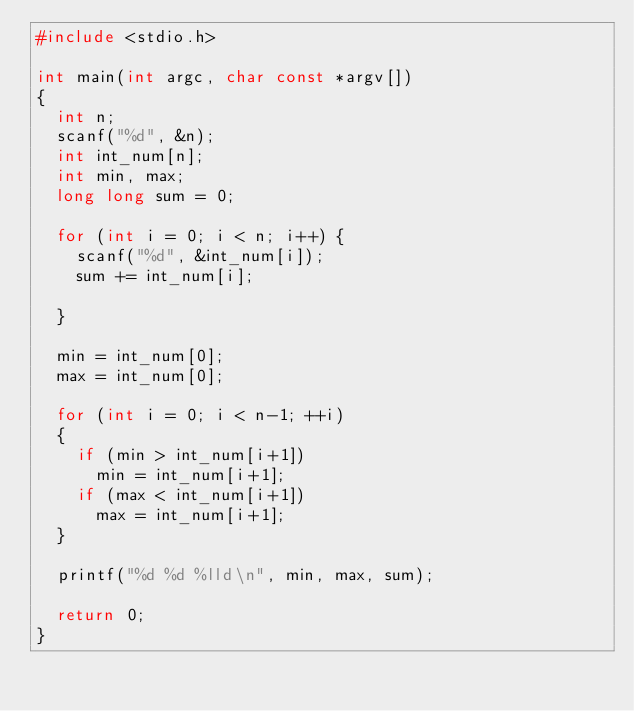Convert code to text. <code><loc_0><loc_0><loc_500><loc_500><_C_>#include <stdio.h>

int main(int argc, char const *argv[])
{
	int n;
	scanf("%d", &n);
	int int_num[n];
	int min, max;
	long long sum = 0;
	
	for (int i = 0; i < n; i++) {
		scanf("%d", &int_num[i]);
		sum += int_num[i];
	
	}
	
	min = int_num[0];
	max = int_num[0];

	for (int i = 0; i < n-1; ++i)
	{
		if (min > int_num[i+1])
			min = int_num[i+1];
		if (max < int_num[i+1])
			max = int_num[i+1];
	}

	printf("%d %d %lld\n", min, max, sum);

	return 0;
}
</code> 